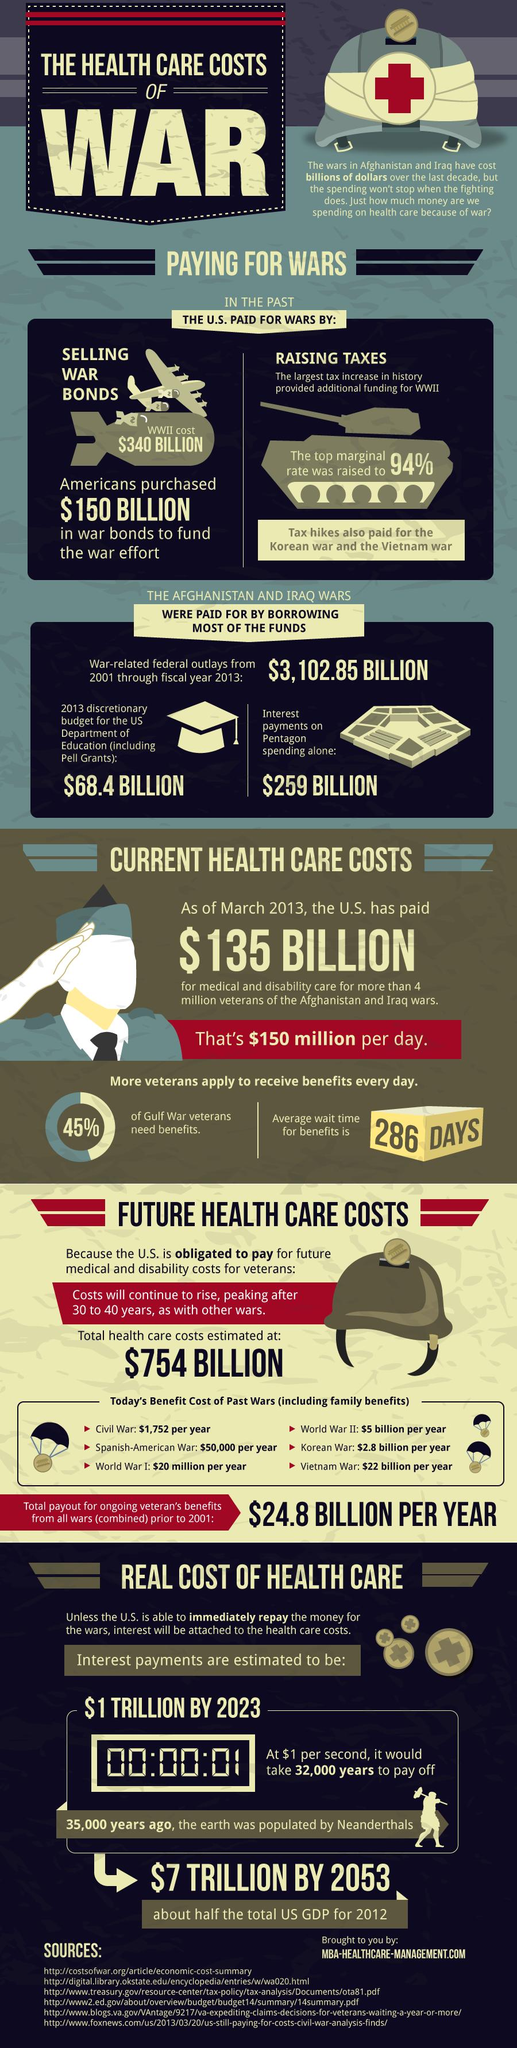Specify some key components in this picture. In 2020, interest payments on Pentagon spending totaled $259 billion. The budget for the Department of Education in 2013 was $68.4 billion. 